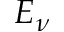Convert formula to latex. <formula><loc_0><loc_0><loc_500><loc_500>E _ { \nu }</formula> 